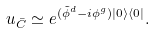<formula> <loc_0><loc_0><loc_500><loc_500>u _ { \bar { C } } \simeq e ^ { ( \tilde { \phi } ^ { d } - i \phi ^ { g } ) | 0 \rangle \langle 0 | } .</formula> 